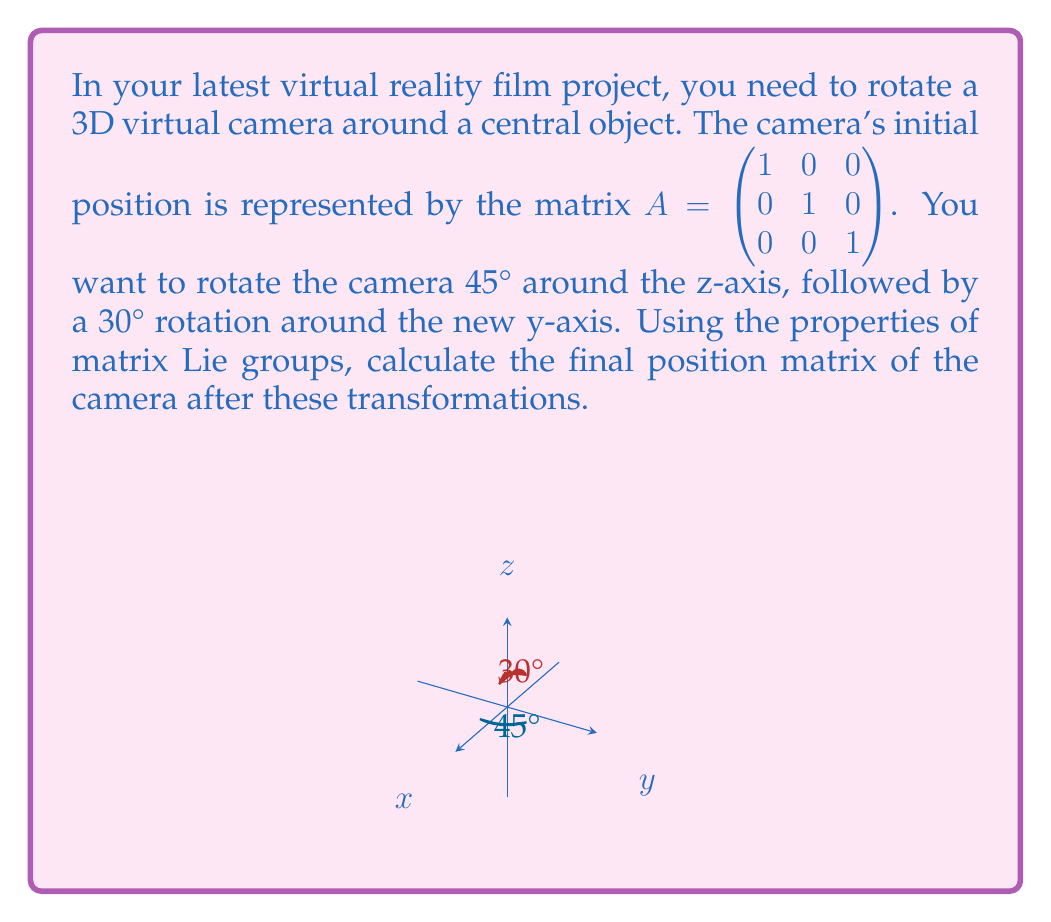Provide a solution to this math problem. Let's approach this step-by-step using the properties of matrix Lie groups:

1) First, we need to represent the rotations as elements of the SO(3) Lie group (special orthogonal group in 3D).

2) The rotation matrix for a 45° rotation around the z-axis is:

   $$R_z(45°) = \begin{pmatrix} \cos 45° & -\sin 45° & 0 \\ \sin 45° & \cos 45° & 0 \\ 0 & 0 & 1 \end{pmatrix} = \begin{pmatrix} \frac{\sqrt{2}}{2} & -\frac{\sqrt{2}}{2} & 0 \\ \frac{\sqrt{2}}{2} & \frac{\sqrt{2}}{2} & 0 \\ 0 & 0 & 1 \end{pmatrix}$$

3) The rotation matrix for a 30° rotation around the y-axis is:

   $$R_y(30°) = \begin{pmatrix} \cos 30° & 0 & \sin 30° \\ 0 & 1 & 0 \\ -\sin 30° & 0 & \cos 30° \end{pmatrix} = \begin{pmatrix} \frac{\sqrt{3}}{2} & 0 & \frac{1}{2} \\ 0 & 1 & 0 \\ -\frac{1}{2} & 0 & \frac{\sqrt{3}}{2} \end{pmatrix}$$

4) In matrix Lie groups, the composition of transformations is represented by matrix multiplication. The order of multiplication is important and should be done from right to left.

5) The final transformation matrix $B$ is given by:

   $$B = R_y(30°) \cdot R_z(45°) \cdot A$$

6) Let's multiply these matrices:

   $$B = \begin{pmatrix} \frac{\sqrt{3}}{2} & 0 & \frac{1}{2} \\ 0 & 1 & 0 \\ -\frac{1}{2} & 0 & \frac{\sqrt{3}}{2} \end{pmatrix} \cdot \begin{pmatrix} \frac{\sqrt{2}}{2} & -\frac{\sqrt{2}}{2} & 0 \\ \frac{\sqrt{2}}{2} & \frac{\sqrt{2}}{2} & 0 \\ 0 & 0 & 1 \end{pmatrix} \cdot \begin{pmatrix} 1 & 0 & 0 \\ 0 & 1 & 0 \\ 0 & 0 & 1 \end{pmatrix}$$

7) Simplifying:

   $$B = \begin{pmatrix} \frac{\sqrt{6}}{4} & -\frac{\sqrt{6}}{4} & \frac{1}{2} \\ \frac{\sqrt{2}}{2} & \frac{\sqrt{2}}{2} & 0 \\ -\frac{\sqrt{6}}{4} & -\frac{\sqrt{6}}{4} & \frac{\sqrt{3}}{2} \end{pmatrix}$$

This final matrix $B$ represents the camera's position after the two rotations.
Answer: $$B = \begin{pmatrix} \frac{\sqrt{6}}{4} & -\frac{\sqrt{6}}{4} & \frac{1}{2} \\ \frac{\sqrt{2}}{2} & \frac{\sqrt{2}}{2} & 0 \\ -\frac{\sqrt{6}}{4} & -\frac{\sqrt{6}}{4} & \frac{\sqrt{3}}{2} \end{pmatrix}$$ 